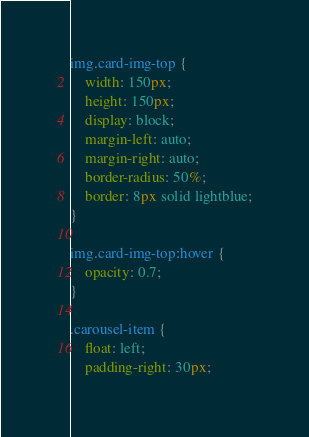Convert code to text. <code><loc_0><loc_0><loc_500><loc_500><_CSS_>img.card-img-top {
    width: 150px;
    height: 150px;
    display: block;
    margin-left: auto;
    margin-right: auto;
    border-radius: 50%;
    border: 8px solid lightblue;
}

img.card-img-top:hover {
    opacity: 0.7;
}

.carousel-item {
    float: left;
    padding-right: 30px;</code> 